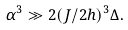Convert formula to latex. <formula><loc_0><loc_0><loc_500><loc_500>\alpha ^ { 3 } \gg 2 ( J / 2 h ) ^ { 3 } \Delta .</formula> 